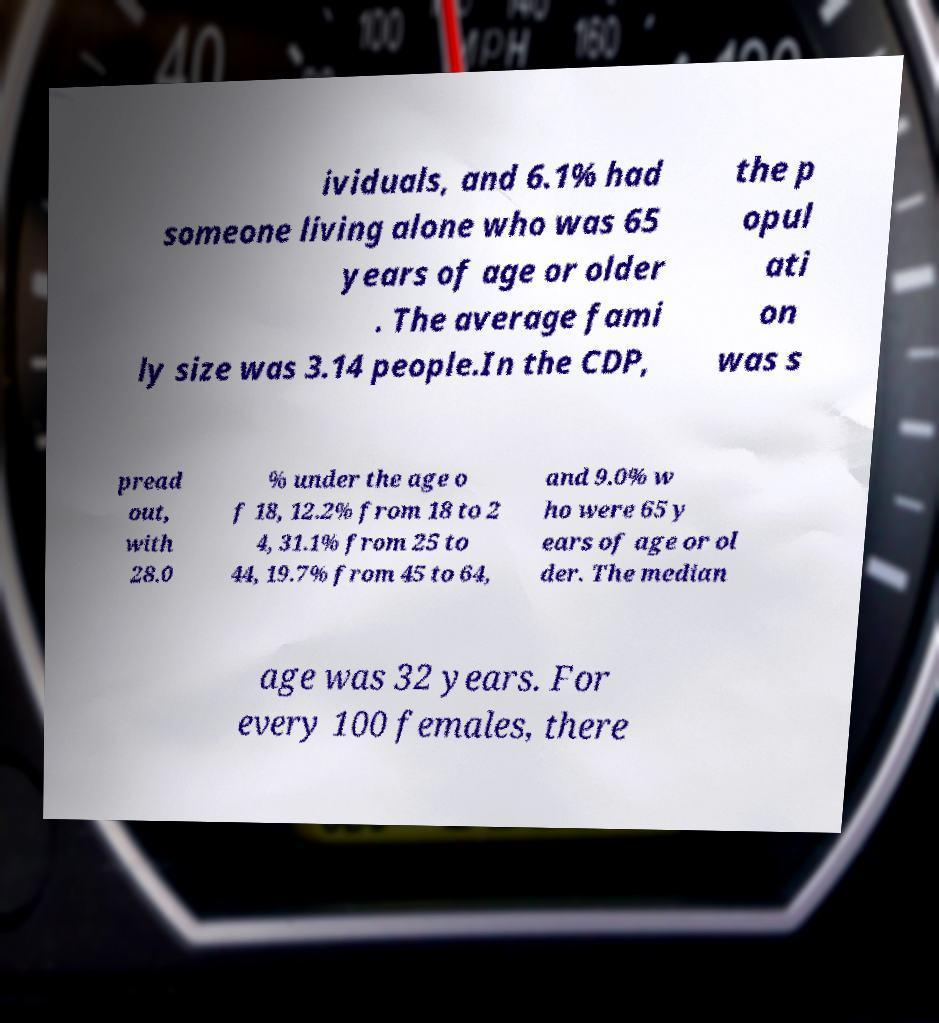Can you accurately transcribe the text from the provided image for me? ividuals, and 6.1% had someone living alone who was 65 years of age or older . The average fami ly size was 3.14 people.In the CDP, the p opul ati on was s pread out, with 28.0 % under the age o f 18, 12.2% from 18 to 2 4, 31.1% from 25 to 44, 19.7% from 45 to 64, and 9.0% w ho were 65 y ears of age or ol der. The median age was 32 years. For every 100 females, there 